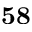<formula> <loc_0><loc_0><loc_500><loc_500>5 8</formula> 